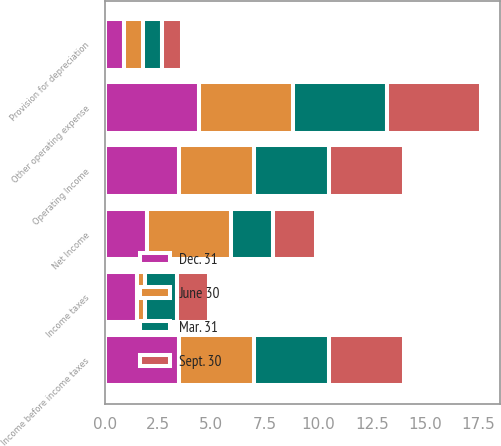Convert chart. <chart><loc_0><loc_0><loc_500><loc_500><stacked_bar_chart><ecel><fcel>Other operating expense<fcel>Provision for depreciation<fcel>Operating Income<fcel>Income before income taxes<fcel>Income taxes<fcel>Net Income<nl><fcel>Mar. 31<fcel>4.4<fcel>0.9<fcel>3.5<fcel>3.5<fcel>1.5<fcel>2<nl><fcel>Dec. 31<fcel>4.4<fcel>0.9<fcel>3.5<fcel>3.5<fcel>1.5<fcel>2<nl><fcel>Sept. 30<fcel>4.4<fcel>0.9<fcel>3.5<fcel>3.5<fcel>1.5<fcel>2<nl><fcel>June 30<fcel>4.4<fcel>0.9<fcel>3.5<fcel>3.5<fcel>0.4<fcel>3.9<nl></chart> 